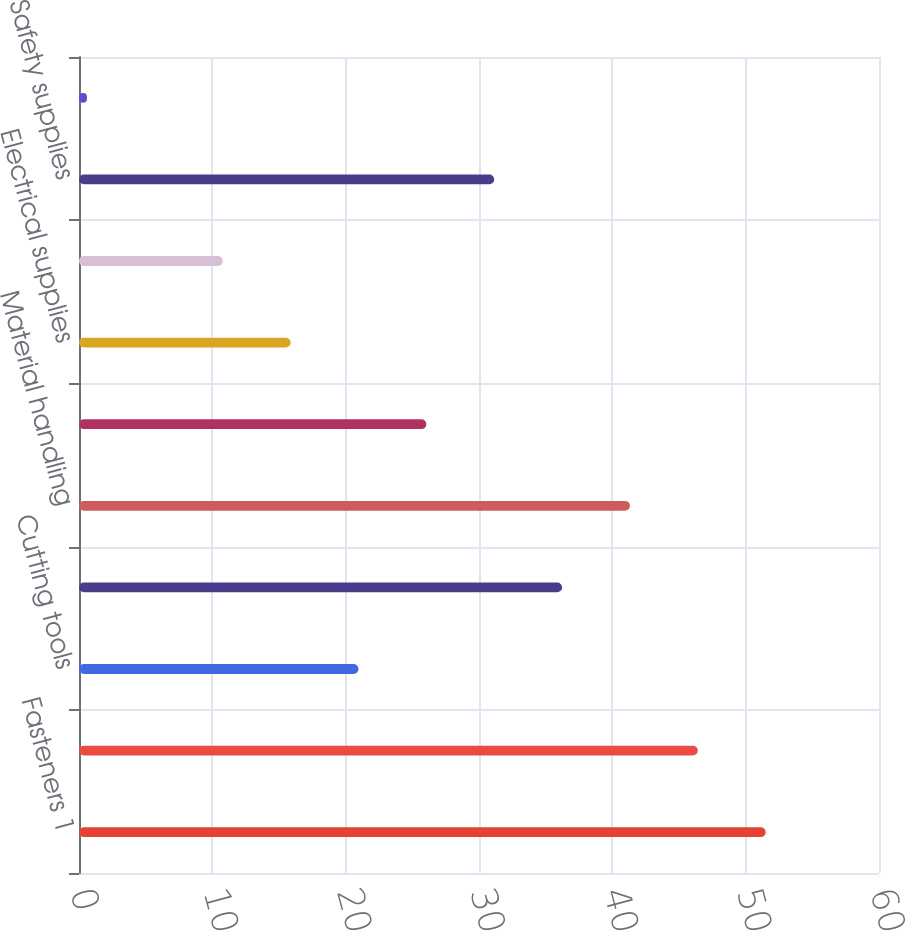<chart> <loc_0><loc_0><loc_500><loc_500><bar_chart><fcel>Fasteners 1<fcel>Tools<fcel>Cutting tools<fcel>Hydraulics & pneumatics<fcel>Material handling<fcel>Janitorial supplies<fcel>Electrical supplies<fcel>Welding supplies<fcel>Safety supplies<fcel>Metals<nl><fcel>51.5<fcel>46.41<fcel>20.96<fcel>36.23<fcel>41.32<fcel>26.05<fcel>15.87<fcel>10.78<fcel>31.14<fcel>0.6<nl></chart> 